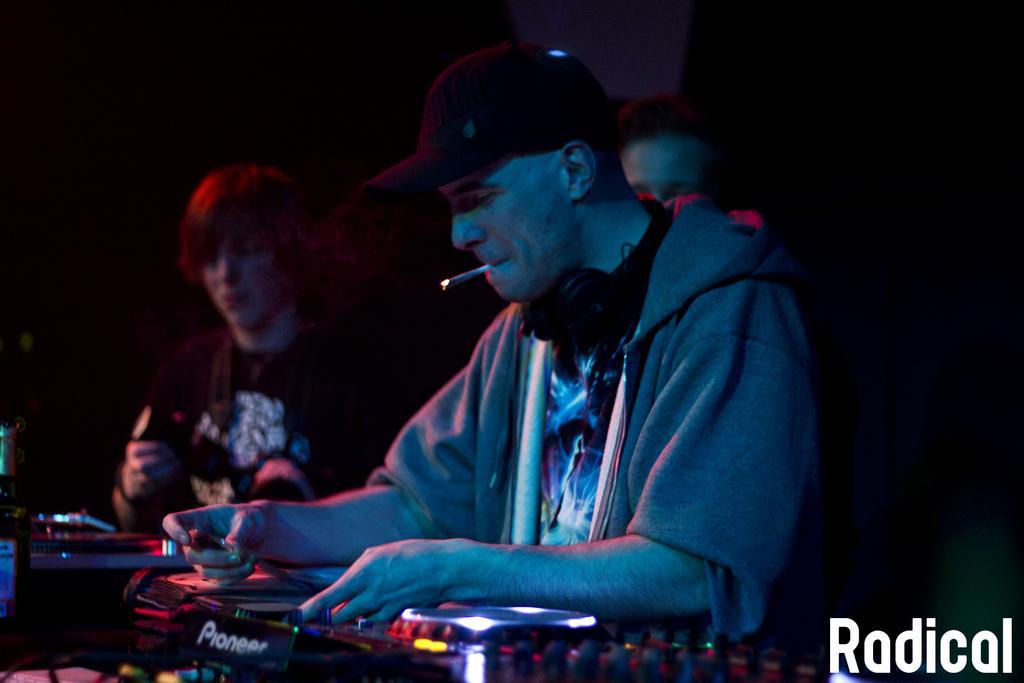Can you describe this image briefly? In this image we can see some people standing. One man is holding an object in his hand. In the foreground of the image we can see some devices placed on the surface. In the bottom right corner of the image we can see some text. 